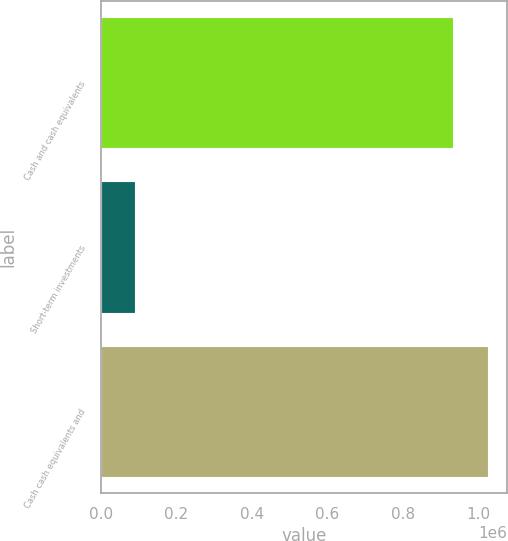<chart> <loc_0><loc_0><loc_500><loc_500><bar_chart><fcel>Cash and cash equivalents<fcel>Short-term investments<fcel>Cash cash equivalents and<nl><fcel>932161<fcel>90445<fcel>1.02538e+06<nl></chart> 